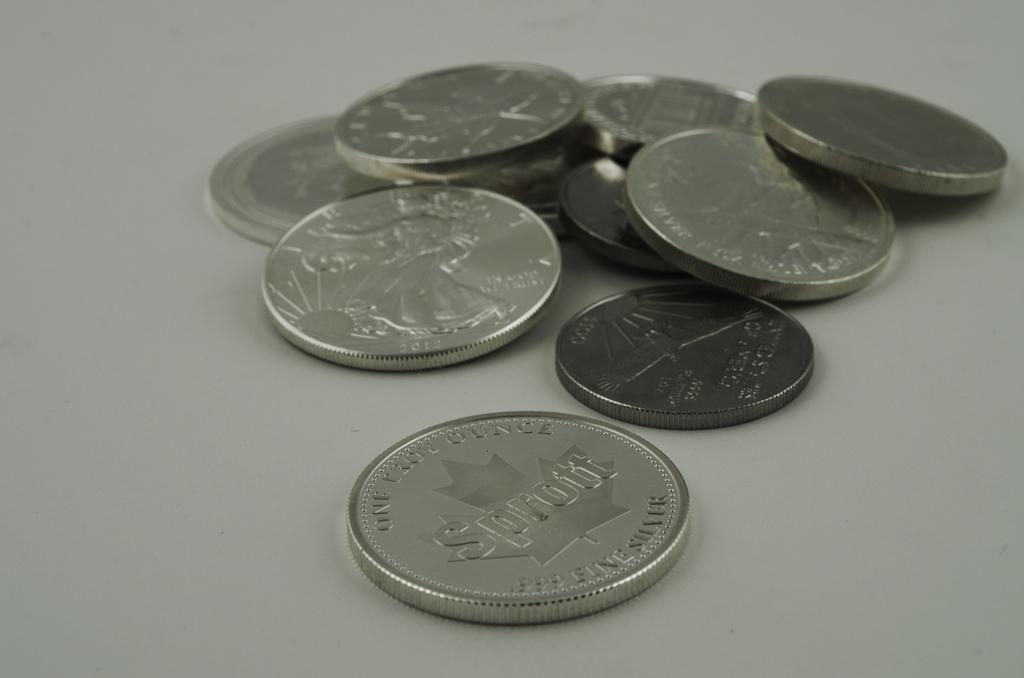What large name is written on the near coin?
Keep it short and to the point. Sprott. 